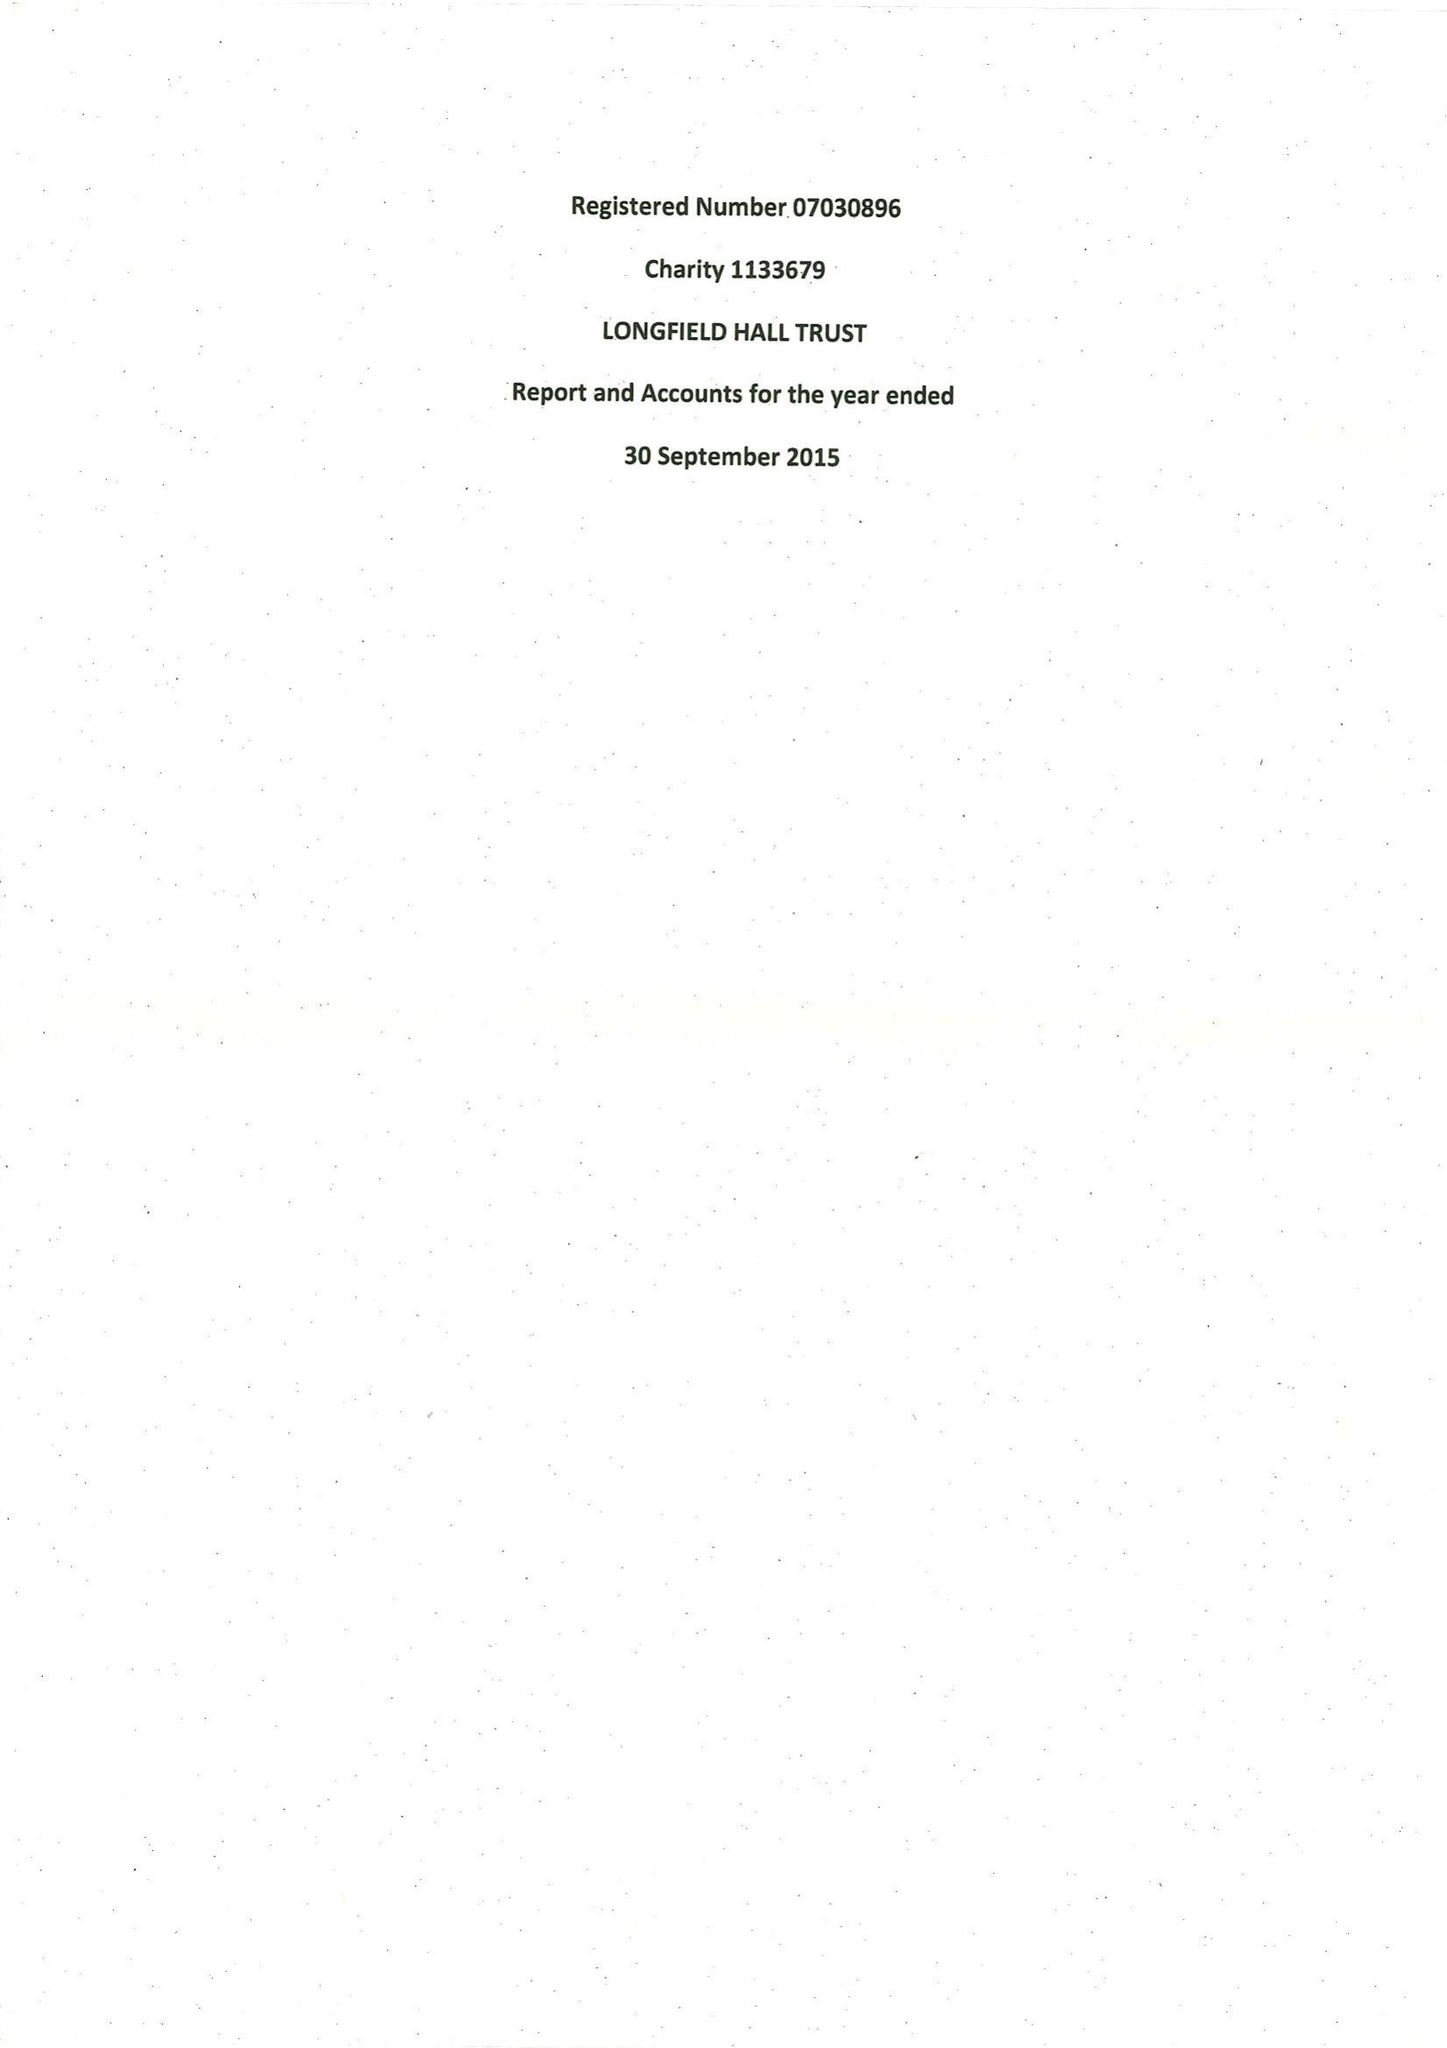What is the value for the address__street_line?
Answer the question using a single word or phrase. 50 KNATCHBULL ROAD 